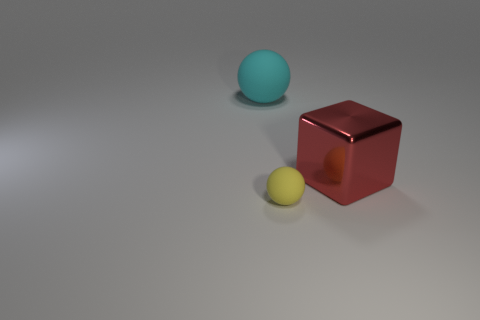Subtract 2 spheres. How many spheres are left? 0 Add 2 large gray balls. How many objects exist? 5 Subtract all yellow spheres. How many spheres are left? 1 Subtract all spheres. How many objects are left? 1 Add 1 large cyan balls. How many large cyan balls are left? 2 Add 2 large red metal blocks. How many large red metal blocks exist? 3 Subtract 1 cyan balls. How many objects are left? 2 Subtract all yellow cubes. Subtract all blue cylinders. How many cubes are left? 1 Subtract all yellow metallic things. Subtract all yellow objects. How many objects are left? 2 